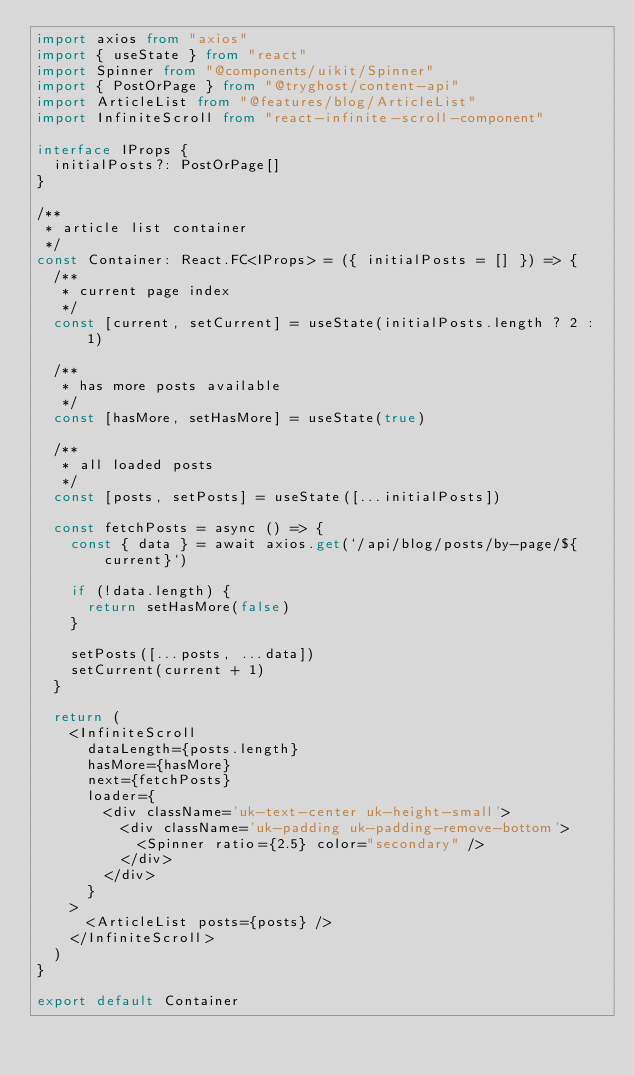Convert code to text. <code><loc_0><loc_0><loc_500><loc_500><_TypeScript_>import axios from "axios"
import { useState } from "react"
import Spinner from "@components/uikit/Spinner"
import { PostOrPage } from "@tryghost/content-api"
import ArticleList from "@features/blog/ArticleList"
import InfiniteScroll from "react-infinite-scroll-component"

interface IProps {
  initialPosts?: PostOrPage[]
}

/**
 * article list container
 */
const Container: React.FC<IProps> = ({ initialPosts = [] }) => {
  /**
   * current page index
   */
  const [current, setCurrent] = useState(initialPosts.length ? 2 : 1)

  /**
   * has more posts available
   */
  const [hasMore, setHasMore] = useState(true)

  /**
   * all loaded posts
   */
  const [posts, setPosts] = useState([...initialPosts])

  const fetchPosts = async () => {
    const { data } = await axios.get(`/api/blog/posts/by-page/${current}`)
    
    if (!data.length) {
      return setHasMore(false)
    }

    setPosts([...posts, ...data])
    setCurrent(current + 1)
  }

  return (
    <InfiniteScroll
      dataLength={posts.length}
      hasMore={hasMore}
      next={fetchPosts}
      loader={
        <div className='uk-text-center uk-height-small'>
          <div className='uk-padding uk-padding-remove-bottom'>
            <Spinner ratio={2.5} color="secondary" />
          </div>
        </div>
      }
    >
      <ArticleList posts={posts} />
    </InfiniteScroll>
  )
}

export default Container</code> 